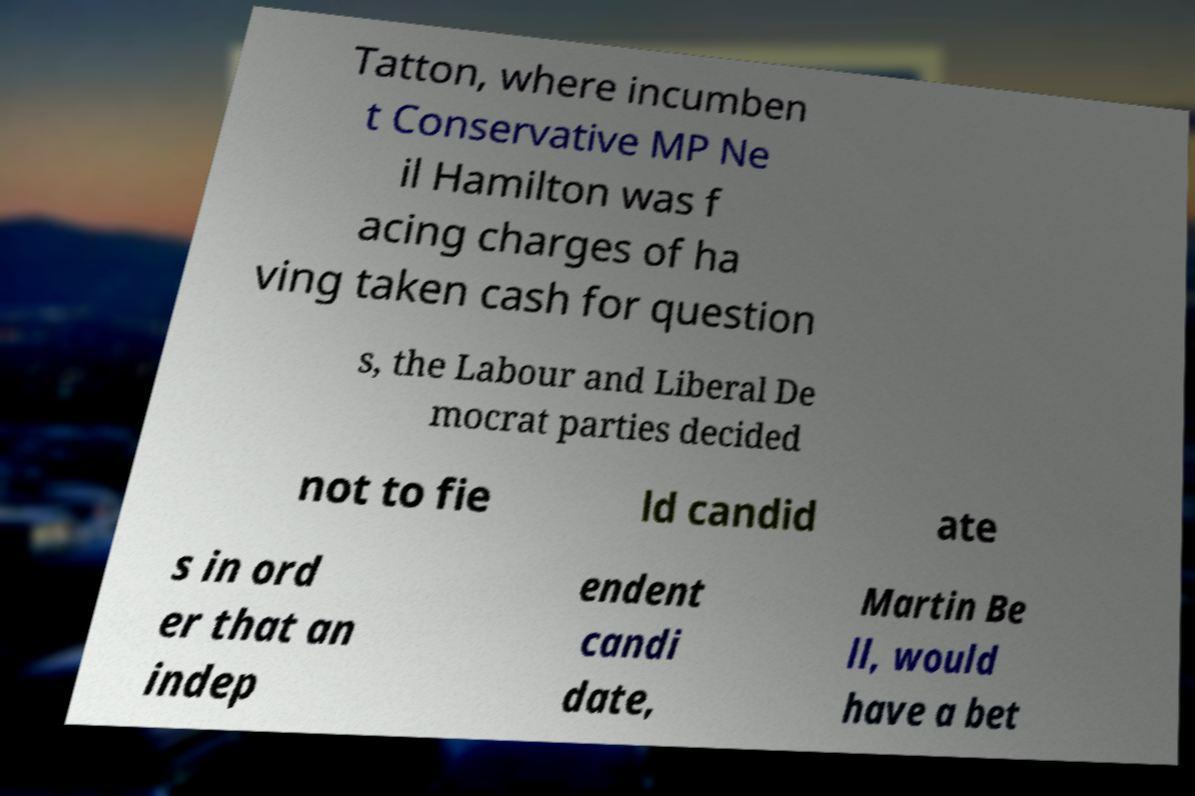Please identify and transcribe the text found in this image. Tatton, where incumben t Conservative MP Ne il Hamilton was f acing charges of ha ving taken cash for question s, the Labour and Liberal De mocrat parties decided not to fie ld candid ate s in ord er that an indep endent candi date, Martin Be ll, would have a bet 